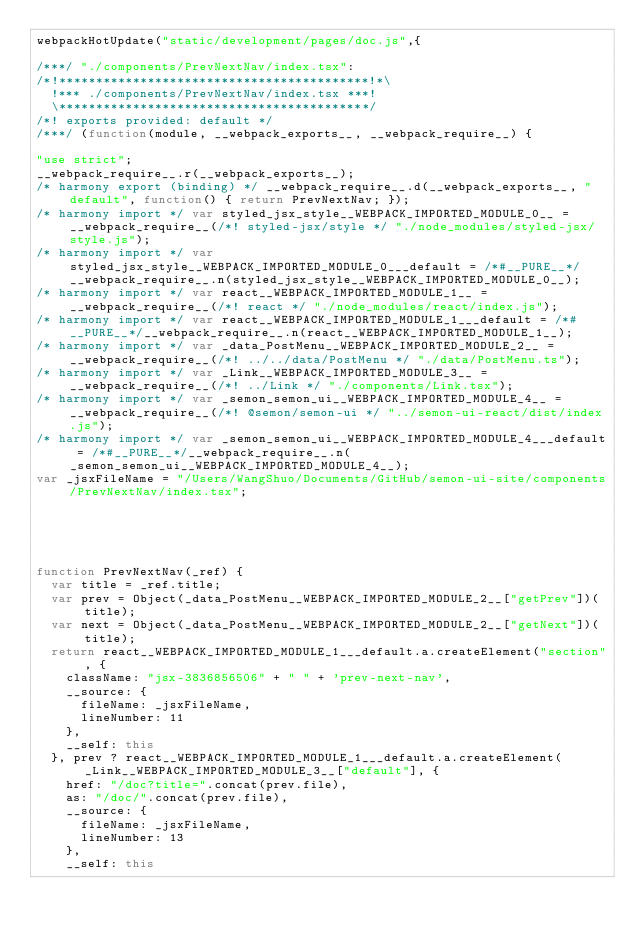Convert code to text. <code><loc_0><loc_0><loc_500><loc_500><_JavaScript_>webpackHotUpdate("static/development/pages/doc.js",{

/***/ "./components/PrevNextNav/index.tsx":
/*!******************************************!*\
  !*** ./components/PrevNextNav/index.tsx ***!
  \******************************************/
/*! exports provided: default */
/***/ (function(module, __webpack_exports__, __webpack_require__) {

"use strict";
__webpack_require__.r(__webpack_exports__);
/* harmony export (binding) */ __webpack_require__.d(__webpack_exports__, "default", function() { return PrevNextNav; });
/* harmony import */ var styled_jsx_style__WEBPACK_IMPORTED_MODULE_0__ = __webpack_require__(/*! styled-jsx/style */ "./node_modules/styled-jsx/style.js");
/* harmony import */ var styled_jsx_style__WEBPACK_IMPORTED_MODULE_0___default = /*#__PURE__*/__webpack_require__.n(styled_jsx_style__WEBPACK_IMPORTED_MODULE_0__);
/* harmony import */ var react__WEBPACK_IMPORTED_MODULE_1__ = __webpack_require__(/*! react */ "./node_modules/react/index.js");
/* harmony import */ var react__WEBPACK_IMPORTED_MODULE_1___default = /*#__PURE__*/__webpack_require__.n(react__WEBPACK_IMPORTED_MODULE_1__);
/* harmony import */ var _data_PostMenu__WEBPACK_IMPORTED_MODULE_2__ = __webpack_require__(/*! ../../data/PostMenu */ "./data/PostMenu.ts");
/* harmony import */ var _Link__WEBPACK_IMPORTED_MODULE_3__ = __webpack_require__(/*! ../Link */ "./components/Link.tsx");
/* harmony import */ var _semon_semon_ui__WEBPACK_IMPORTED_MODULE_4__ = __webpack_require__(/*! @semon/semon-ui */ "../semon-ui-react/dist/index.js");
/* harmony import */ var _semon_semon_ui__WEBPACK_IMPORTED_MODULE_4___default = /*#__PURE__*/__webpack_require__.n(_semon_semon_ui__WEBPACK_IMPORTED_MODULE_4__);
var _jsxFileName = "/Users/WangShuo/Documents/GitHub/semon-ui-site/components/PrevNextNav/index.tsx";





function PrevNextNav(_ref) {
  var title = _ref.title;
  var prev = Object(_data_PostMenu__WEBPACK_IMPORTED_MODULE_2__["getPrev"])(title);
  var next = Object(_data_PostMenu__WEBPACK_IMPORTED_MODULE_2__["getNext"])(title);
  return react__WEBPACK_IMPORTED_MODULE_1___default.a.createElement("section", {
    className: "jsx-3836856506" + " " + 'prev-next-nav',
    __source: {
      fileName: _jsxFileName,
      lineNumber: 11
    },
    __self: this
  }, prev ? react__WEBPACK_IMPORTED_MODULE_1___default.a.createElement(_Link__WEBPACK_IMPORTED_MODULE_3__["default"], {
    href: "/doc?title=".concat(prev.file),
    as: "/doc/".concat(prev.file),
    __source: {
      fileName: _jsxFileName,
      lineNumber: 13
    },
    __self: this</code> 